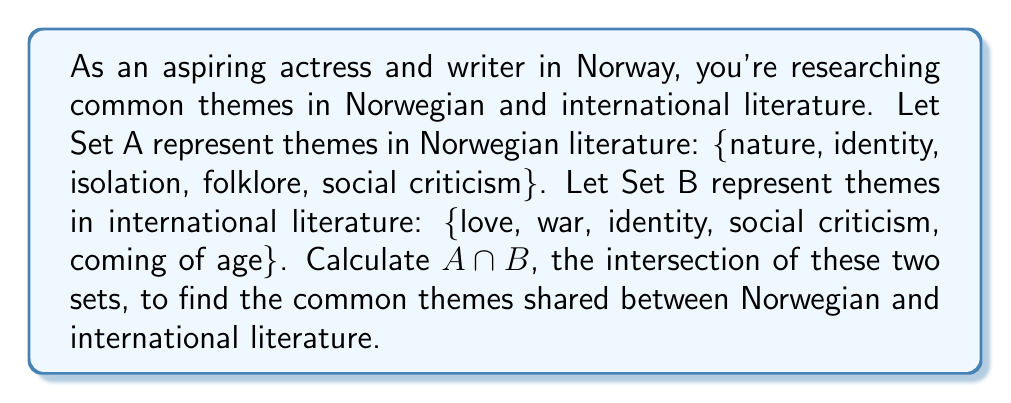Provide a solution to this math problem. To find the intersection of two sets, we need to identify the elements that are present in both sets. Let's examine each element:

1. nature: Only in Set A
2. identity: In both Set A and Set B
3. isolation: Only in Set A
4. folklore: Only in Set A
5. social criticism: In both Set A and Set B
6. love: Only in Set B
7. war: Only in Set B
8. coming of age: Only in Set B

The intersection $A \cap B$ contains all elements that appear in both Set A and Set B. From our analysis, we can see that "identity" and "social criticism" are the only elements present in both sets.

Therefore, the intersection can be written as:

$$A \cap B = \{identity, social criticism\}$$

This result shows that identity and social criticism are common themes shared between Norwegian and international literature, which could be valuable knowledge for an aspiring writer looking to blend Norwegian and international literary traditions.
Answer: $A \cap B = \{identity, social criticism\}$ 